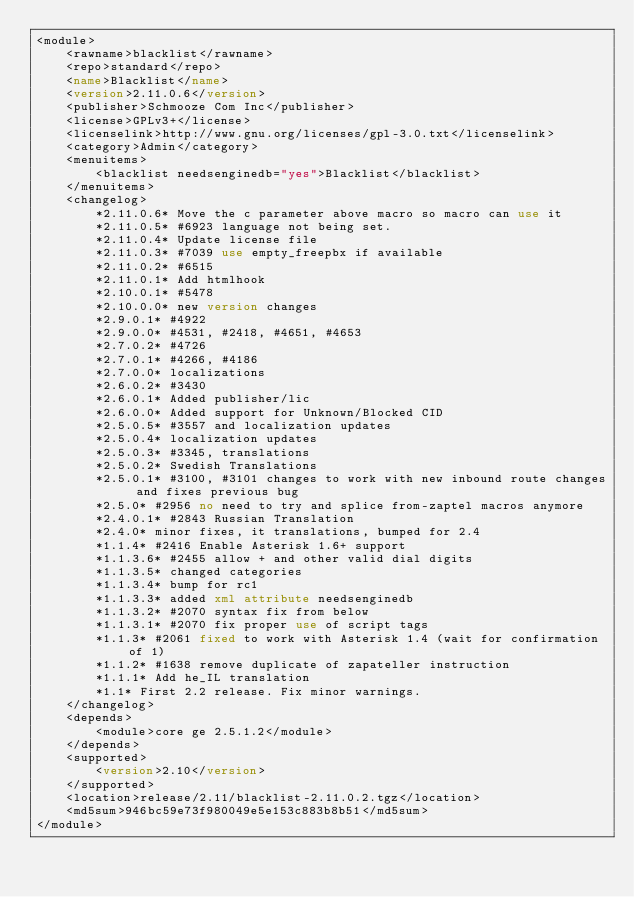<code> <loc_0><loc_0><loc_500><loc_500><_XML_><module>
	<rawname>blacklist</rawname>
	<repo>standard</repo>
	<name>Blacklist</name>
	<version>2.11.0.6</version>
	<publisher>Schmooze Com Inc</publisher>
	<license>GPLv3+</license>
	<licenselink>http://www.gnu.org/licenses/gpl-3.0.txt</licenselink>
	<category>Admin</category>
	<menuitems>
		<blacklist needsenginedb="yes">Blacklist</blacklist>
	</menuitems>
	<changelog>
		*2.11.0.6* Move the c parameter above macro so macro can use it
		*2.11.0.5* #6923 language not being set.
		*2.11.0.4* Update license file
		*2.11.0.3* #7039 use empty_freepbx if available
		*2.11.0.2* #6515
		*2.11.0.1* Add htmlhook
		*2.10.0.1* #5478 
		*2.10.0.0* new version changes
		*2.9.0.1* #4922
		*2.9.0.0* #4531, #2418, #4651, #4653
		*2.7.0.2* #4726
		*2.7.0.1* #4266, #4186
		*2.7.0.0* localizations
		*2.6.0.2* #3430
		*2.6.0.1* Added publisher/lic
		*2.6.0.0* Added support for Unknown/Blocked CID
		*2.5.0.5* #3557 and localization updates
		*2.5.0.4* localization updates
		*2.5.0.3* #3345, translations
		*2.5.0.2* Swedish Translations
		*2.5.0.1* #3100, #3101 changes to work with new inbound route changes and fixes previous bug
		*2.5.0* #2956 no need to try and splice from-zaptel macros anymore
		*2.4.0.1* #2843 Russian Translation
		*2.4.0* minor fixes, it translations, bumped for 2.4
		*1.1.4* #2416 Enable Asterisk 1.6+ support
		*1.1.3.6* #2455 allow + and other valid dial digits
		*1.1.3.5* changed categories
		*1.1.3.4* bump for rc1
		*1.1.3.3* added xml attribute needsenginedb
		*1.1.3.2* #2070 syntax fix from below
		*1.1.3.1* #2070 fix proper use of script tags
		*1.1.3* #2061 fixed to work with Asterisk 1.4 (wait for confirmation of 1)
		*1.1.2* #1638 remove duplicate of zapateller instruction
		*1.1.1* Add he_IL translation
		*1.1* First 2.2 release. Fix minor warnings.
	</changelog>
	<depends>
		<module>core ge 2.5.1.2</module>
	</depends>
	<supported>
		<version>2.10</version>
	</supported>
	<location>release/2.11/blacklist-2.11.0.2.tgz</location>
	<md5sum>946bc59e73f980049e5e153c883b8b51</md5sum>
</module>
</code> 